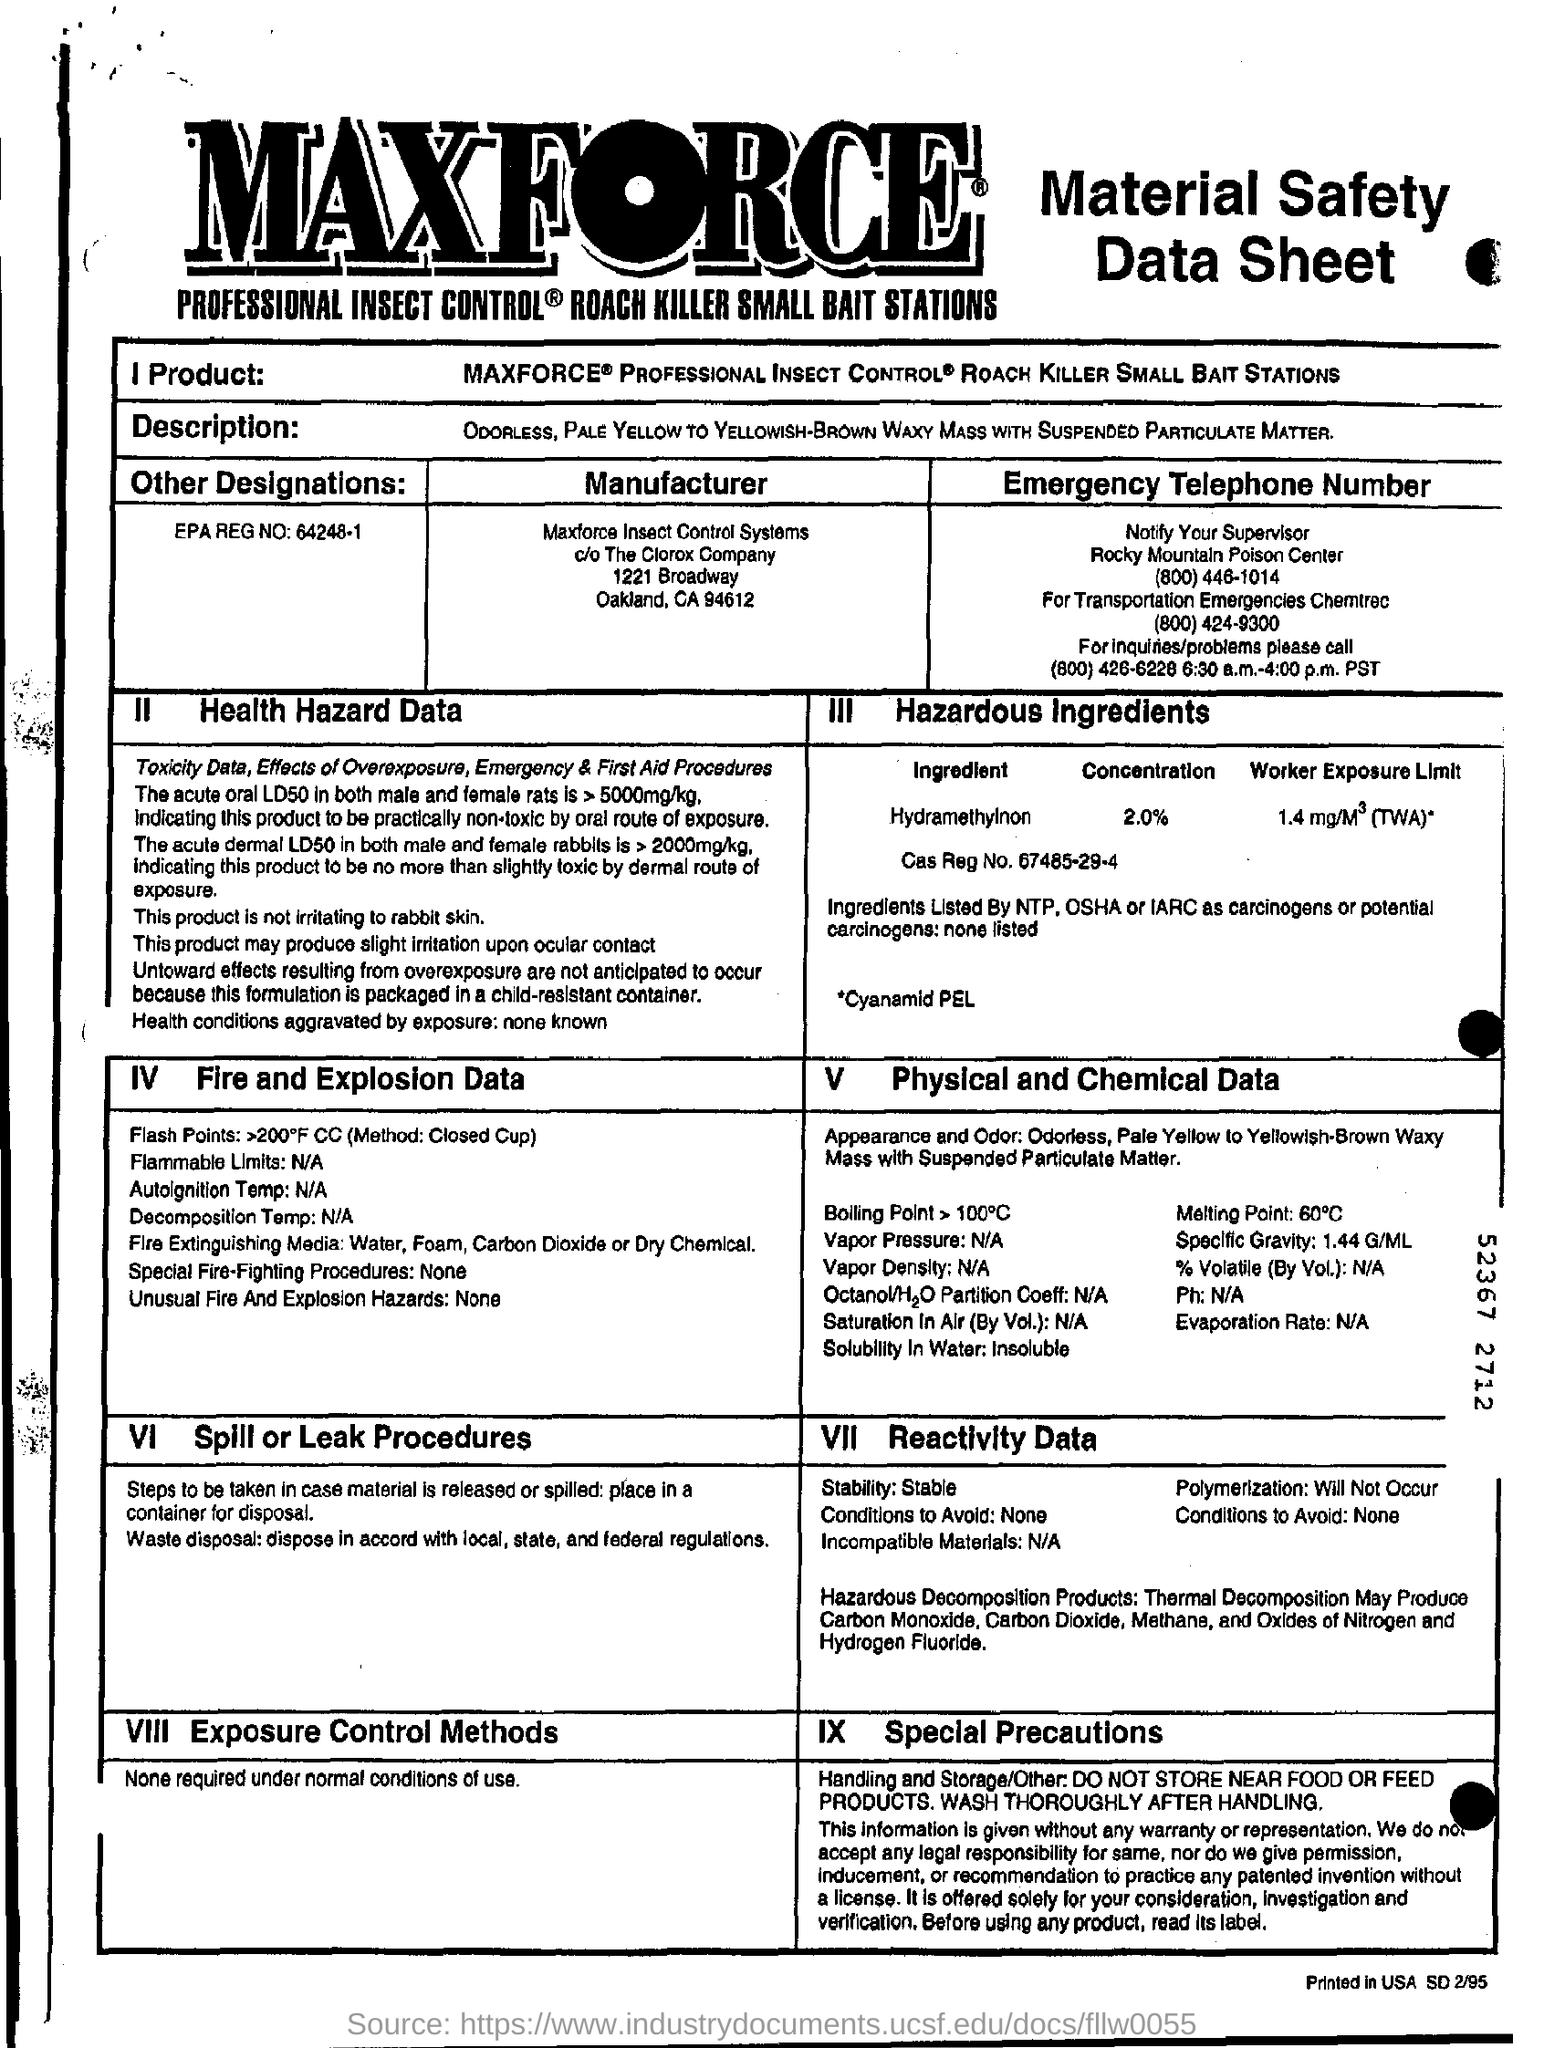Mention a couple of crucial points in this snapshot. MAXFORCE INSECT CONTROL SYSTEMS is the manufacturer of the insecticide used in the study. What is the EPA REG NO? It is 64248-1. The Cas Reg No. is 67485-29-4. Hydramethylnon can be safely used at a concentration of up to 2.0%, with no adverse effects on the treated pests. 